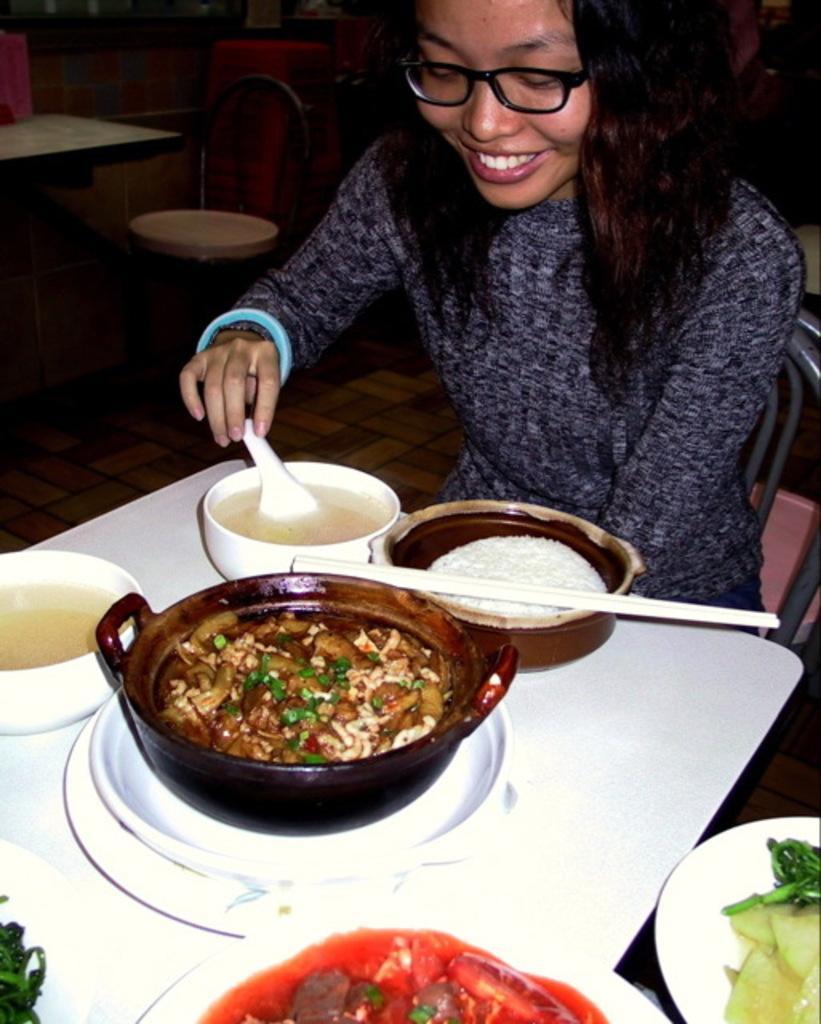How would you summarize this image in a sentence or two? In this image we can see a person sitting on the chair. There is some food in the plates. There is some soup in the bowls. There are few tables and chairs in the image. 